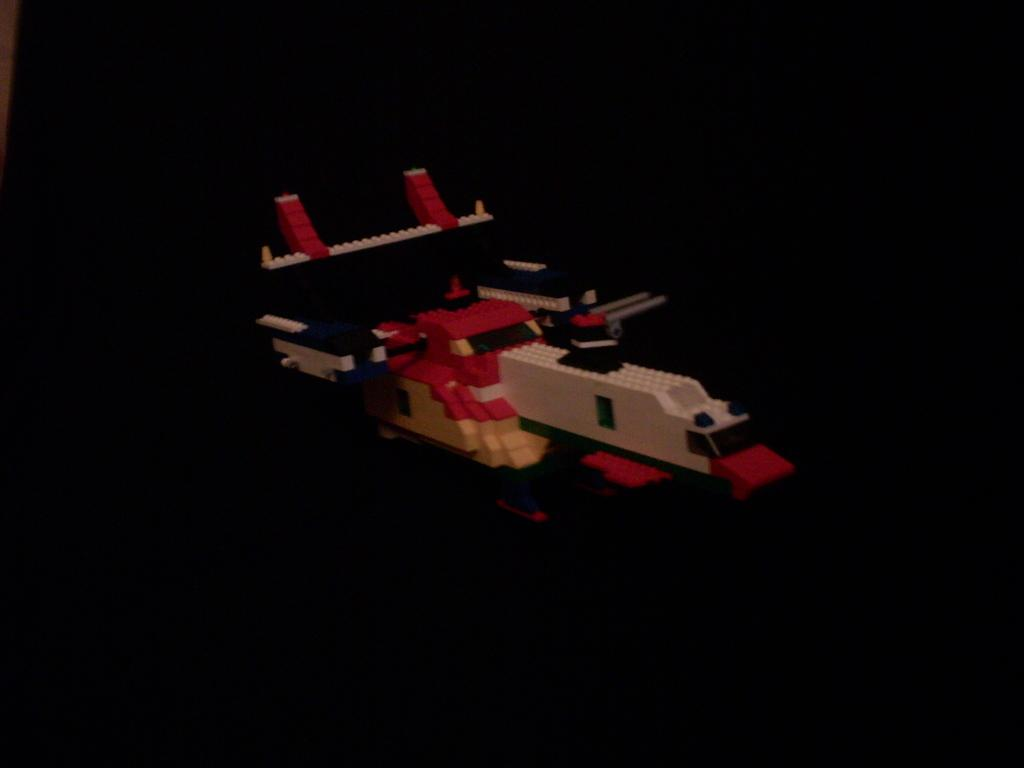What is the main object in the image? There is a toy in the image. Can you describe the background of the image? The background of the image is dark. Who is the owner of the toy in the image? There is no information about the owner of the toy in the image. Can you see any sea or airplane in the image? There is no sea or airplane present in the image. 